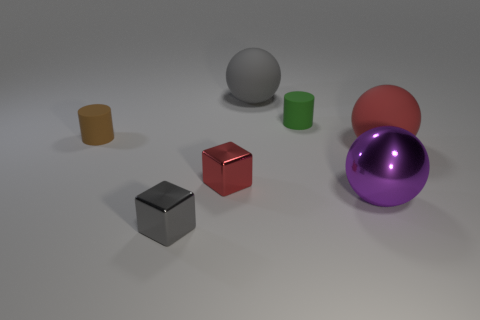Is the material of the small cube that is in front of the big purple shiny sphere the same as the big gray ball?
Make the answer very short. No. What is the material of the red object that is on the left side of the cylinder that is right of the large gray object?
Offer a very short reply. Metal. What number of tiny brown things have the same shape as the gray metal thing?
Provide a short and direct response. 0. How big is the cylinder behind the tiny matte cylinder that is in front of the tiny matte cylinder that is to the right of the gray matte object?
Provide a short and direct response. Small. What number of brown things are either metallic cubes or tiny things?
Keep it short and to the point. 1. There is a big object behind the green cylinder; is its shape the same as the large purple object?
Your answer should be very brief. Yes. Is the number of matte balls that are right of the tiny brown matte cylinder greater than the number of tiny green cylinders?
Make the answer very short. Yes. How many gray metal cubes have the same size as the purple metal ball?
Your response must be concise. 0. How many things are either small green matte cylinders or rubber cylinders behind the tiny brown object?
Offer a very short reply. 1. What is the color of the thing that is both to the right of the gray rubber object and in front of the red metal cube?
Your response must be concise. Purple. 